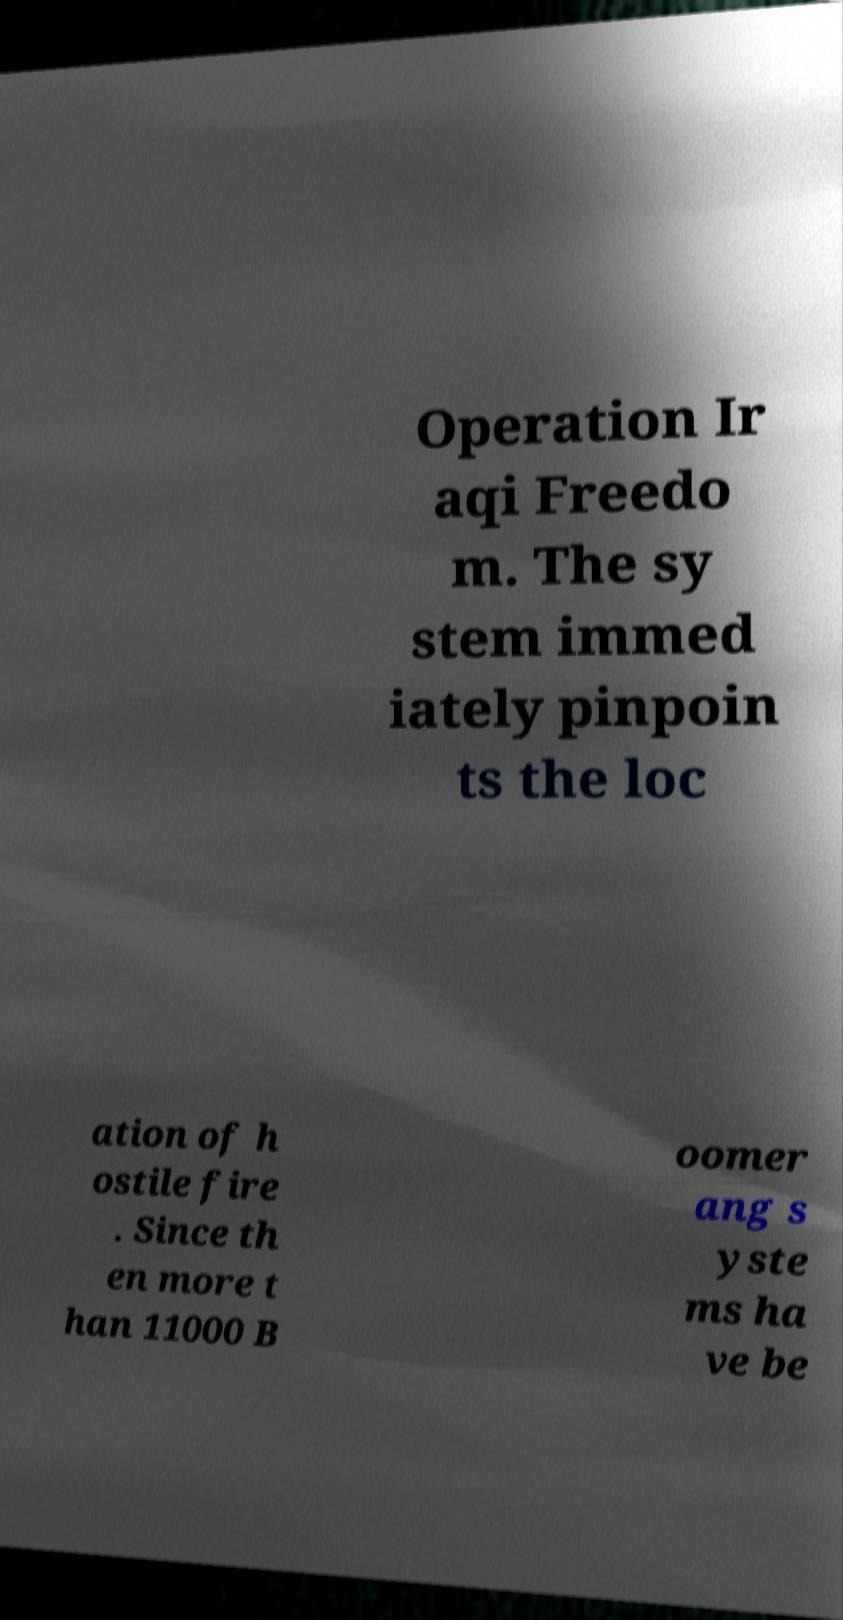Please identify and transcribe the text found in this image. Operation Ir aqi Freedo m. The sy stem immed iately pinpoin ts the loc ation of h ostile fire . Since th en more t han 11000 B oomer ang s yste ms ha ve be 